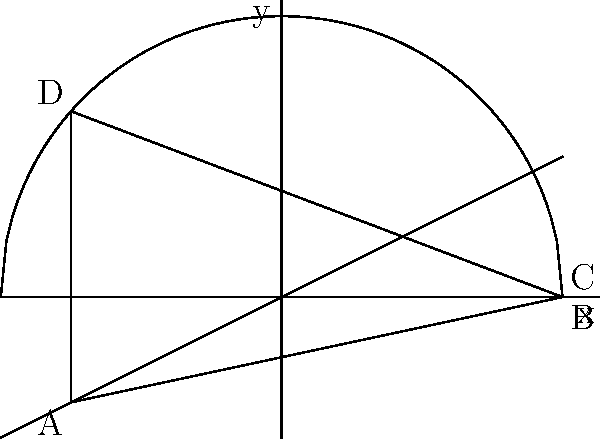At a recent crime scene, you've encountered an irregularly shaped area bounded by two functions: $f(x) = \sqrt{16-x^2}$ and $g(x) = \frac{x}{2}$, from $x=-3$ to $x=4$. Calculate the area of this crime scene using coordinate geometry and integration. Round your answer to two decimal places. To find the area of the irregularly shaped crime scene, we need to:

1. Identify the area to be calculated:
   The area is bounded by $f(x) = \sqrt{16-x^2}$ (upper curve) and $g(x) = \frac{x}{2}$ (lower line) from $x=-3$ to $x=4$.

2. Set up the integral:
   Area = $\int_{-3}^{4} [f(x) - g(x)] dx$

3. Substitute the functions:
   Area = $\int_{-3}^{4} [\sqrt{16-x^2} - \frac{x}{2}] dx$

4. Evaluate the integral:
   $\int_{-3}^{4} \sqrt{16-x^2} dx - \int_{-3}^{4} \frac{x}{2} dx$

   For the first part, we use trigonometric substitution:
   $x = 4\sin\theta$, $dx = 4\cos\theta d\theta$
   When $x = -3$, $\theta = \arcsin(-\frac{3}{4})$
   When $x = 4$, $\theta = \frac{\pi}{2}$

   $16\int_{\arcsin(-\frac{3}{4})}^{\frac{\pi}{2}} \cos^2\theta d\theta - [\frac{x^2}{4}]_{-3}^{4}$

   $16[\frac{\theta}{2} + \frac{\sin(2\theta)}{4}]_{\arcsin(-\frac{3}{4})}^{\frac{\pi}{2}} - [\frac{16}{4} - \frac{9}{4}]$

   $16[\frac{\pi}{4} - (\frac{\arcsin(-\frac{3}{4})}{2} + \frac{\sqrt{7}}{8})] - \frac{7}{4}$

5. Calculate the final result:
   Area ≈ 23.06 square units
Answer: 23.06 square units 